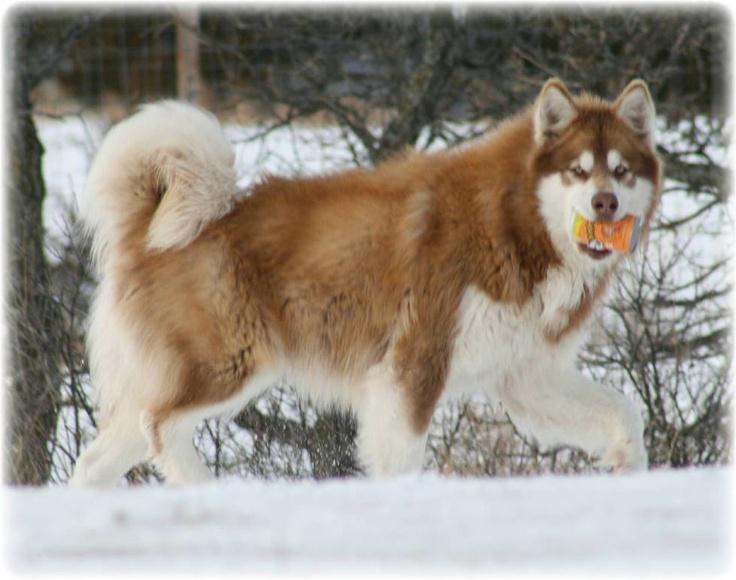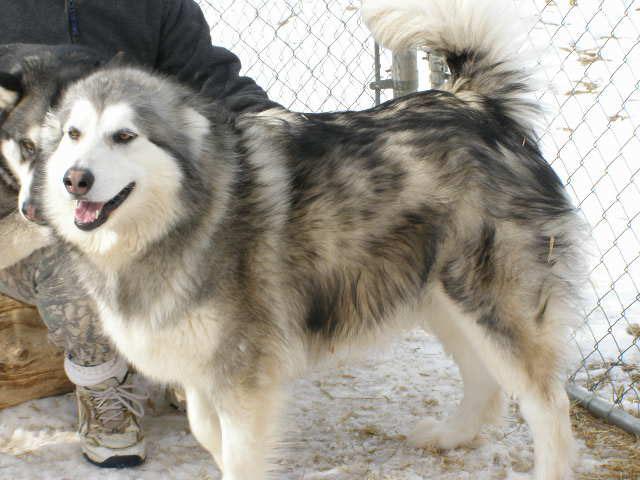The first image is the image on the left, the second image is the image on the right. Considering the images on both sides, is "The foreground of the right image features an open-mouthed husky with a curled, upturned tail standing in profile facing leftward, withone front paw slightly bent and lifted." valid? Answer yes or no. Yes. 